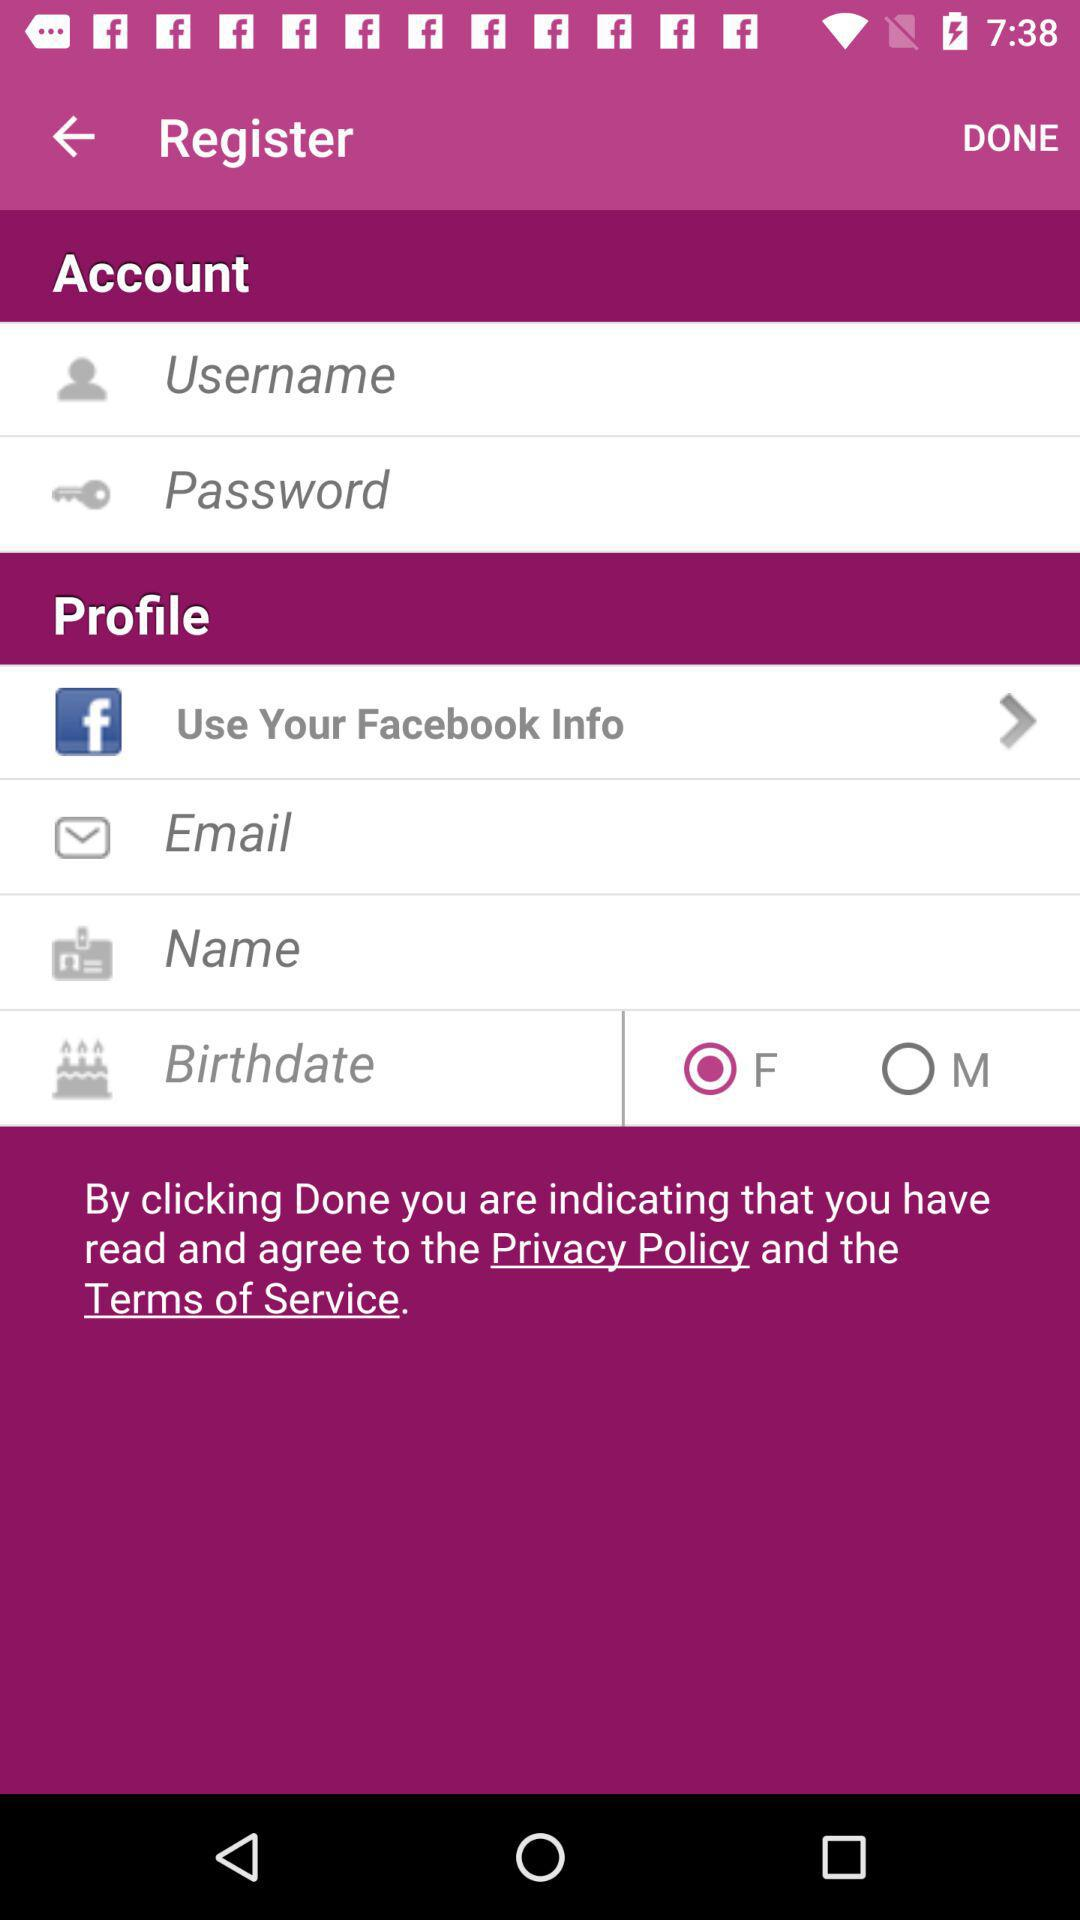Which gender option is selected? The selected option is "F". 